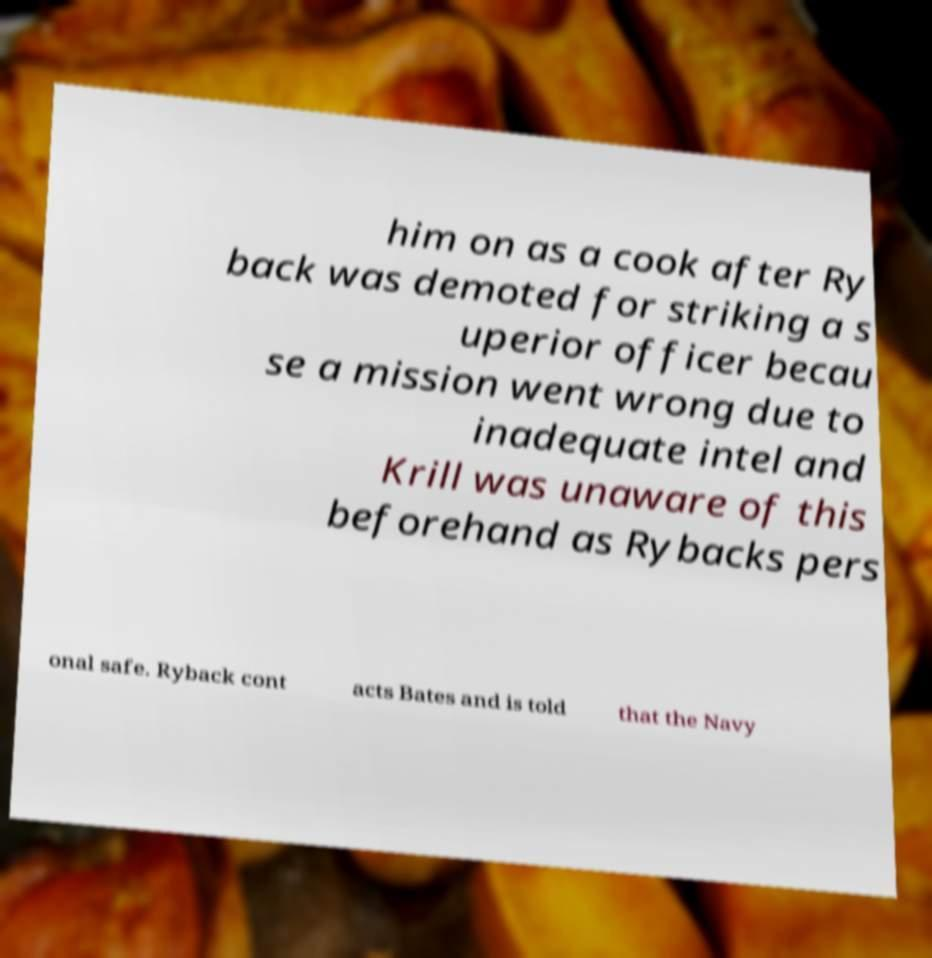For documentation purposes, I need the text within this image transcribed. Could you provide that? him on as a cook after Ry back was demoted for striking a s uperior officer becau se a mission went wrong due to inadequate intel and Krill was unaware of this beforehand as Rybacks pers onal safe. Ryback cont acts Bates and is told that the Navy 